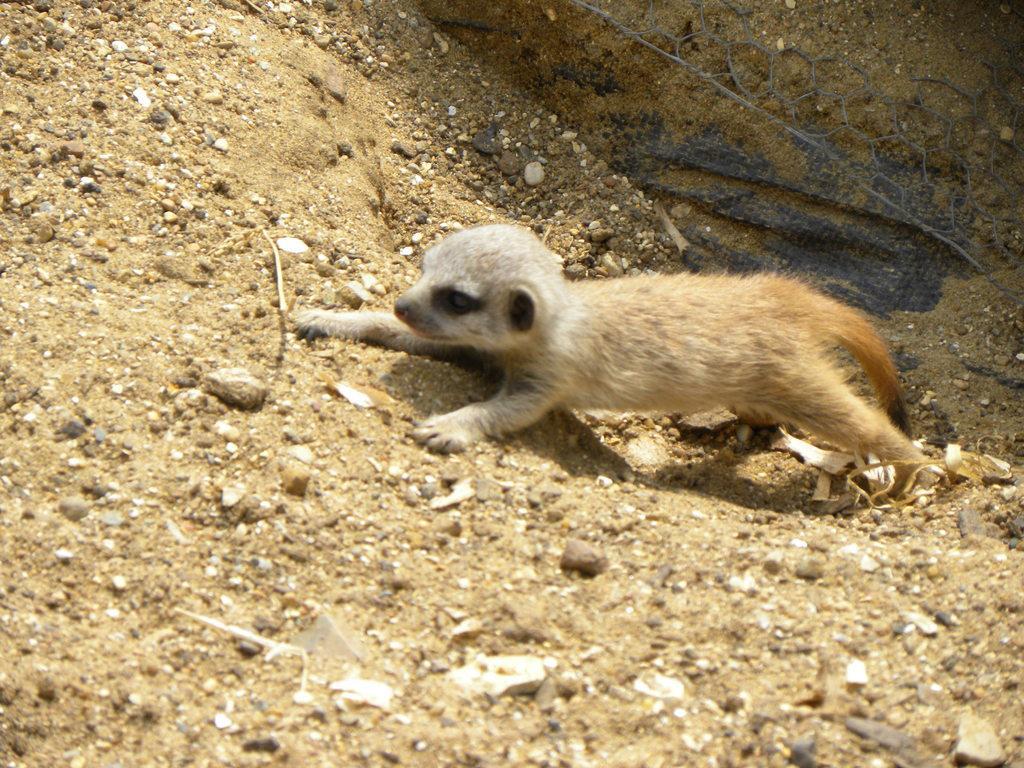Could you give a brief overview of what you see in this image? In the foreground of this image, there is a meerkat on the ground and on the top right, there is a metal mesh and a black colored cloth. 